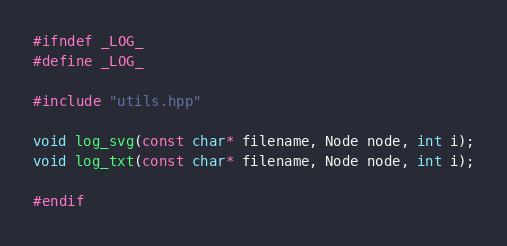Convert code to text. <code><loc_0><loc_0><loc_500><loc_500><_C++_>#ifndef _LOG_
#define _LOG_

#include "utils.hpp"

void log_svg(const char* filename, Node node, int i);
void log_txt(const char* filename, Node node, int i);

#endif
</code> 